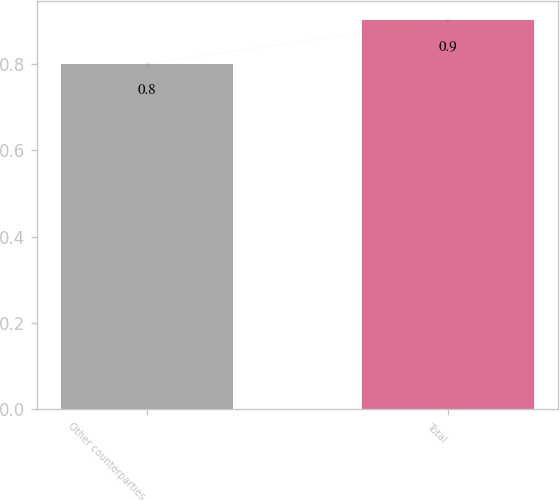Convert chart. <chart><loc_0><loc_0><loc_500><loc_500><bar_chart><fcel>Other counterparties<fcel>Total<nl><fcel>0.8<fcel>0.9<nl></chart> 